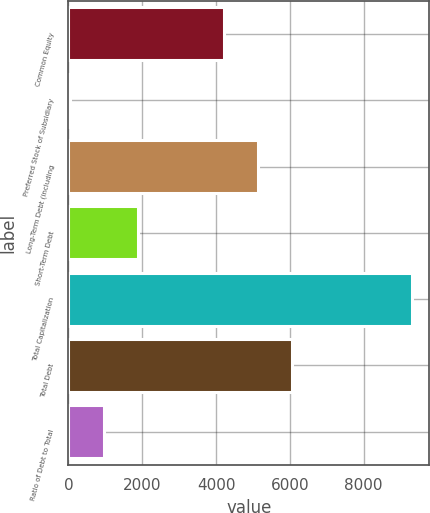Convert chart to OTSL. <chart><loc_0><loc_0><loc_500><loc_500><bar_chart><fcel>Common Equity<fcel>Preferred Stock of Subsidiary<fcel>Long-Term Debt (including<fcel>Short-Term Debt<fcel>Total Capitalization<fcel>Total Debt<fcel>Ratio of Debt to Total<nl><fcel>4213.3<fcel>30.4<fcel>5141.31<fcel>1886.42<fcel>9310.5<fcel>6069.32<fcel>958.41<nl></chart> 